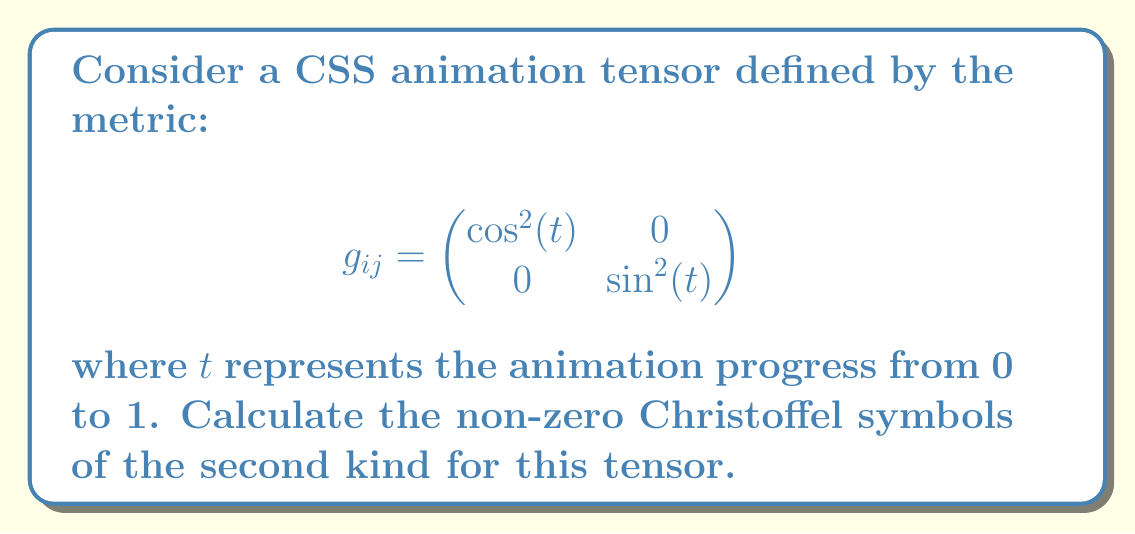Can you solve this math problem? To solve for the Christoffel symbols, we'll follow these steps:

1) The Christoffel symbols of the second kind are given by:

   $$\Gamma^k_{ij} = \frac{1}{2}g^{kl}(\partial_i g_{jl} + \partial_j g_{il} - \partial_l g_{ij})$$

2) First, we need to calculate the inverse metric $g^{ij}$:

   $$g^{ij} = \begin{pmatrix}
   \sec^2(t) & 0 \\
   0 & \csc^2(t)
   \end{pmatrix}$$

3) Now, let's calculate the partial derivatives:

   $$\partial_1 g_{ij} = \begin{pmatrix}
   0 & 0 \\
   0 & 0
   \end{pmatrix}$$

   $$\partial_2 g_{ij} = \begin{pmatrix}
   -2\sin(t)\cos(t) & 0 \\
   0 & 2\sin(t)\cos(t)
   \end{pmatrix}$$

4) We can now calculate each Christoffel symbol:

   $\Gamma^1_{11} = \Gamma^1_{12} = \Gamma^1_{21} = \Gamma^2_{11} = 0$

   $\Gamma^1_{22} = \frac{1}{2}g^{11}(-\partial_2 g_{22}) = -\frac{\sin(t)}{\cos(t)}$

   $\Gamma^2_{12} = \Gamma^2_{21} = \frac{1}{2}g^{22}(\partial_2 g_{12}) = \frac{\cos(t)}{\sin(t)}$

   $\Gamma^2_{22} = 0$

5) The non-zero Christoffel symbols are $\Gamma^1_{22}$ and $\Gamma^2_{12} = \Gamma^2_{21}$.
Answer: $\Gamma^1_{22} = -\tan(t)$, $\Gamma^2_{12} = \Gamma^2_{21} = \cot(t)$ 